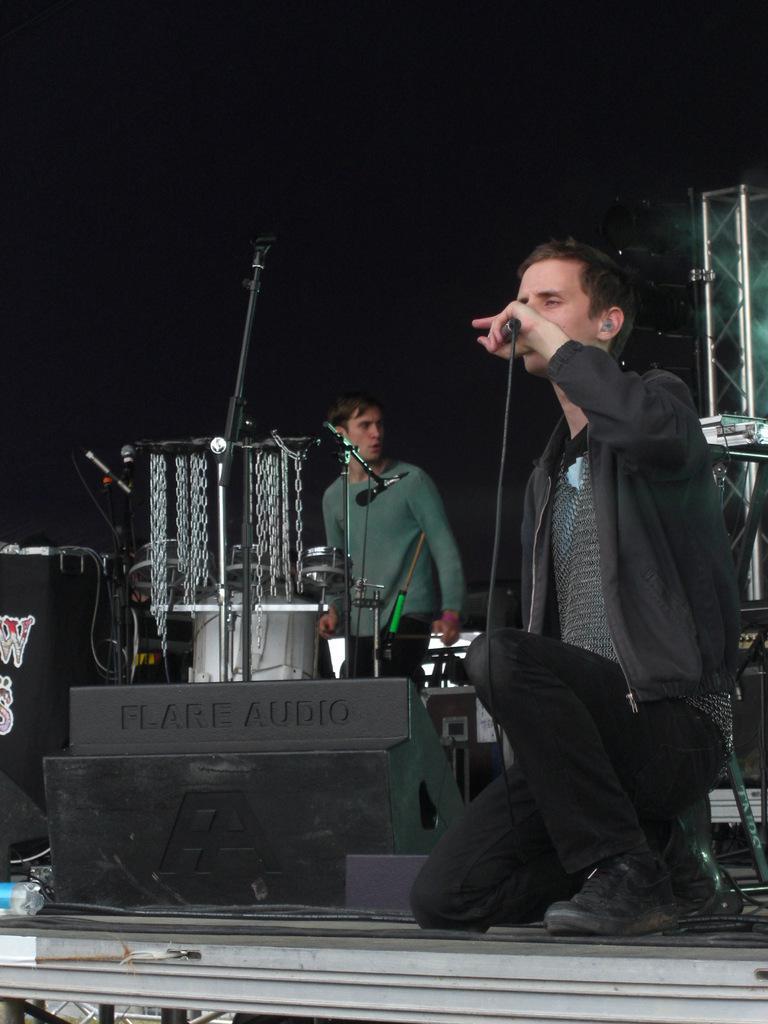In one or two sentences, can you explain what this image depicts? In this picture we can see two men where one is standing and other is sitting on knees he is holding mic in his hand and in background we can see stands, chains and it is dark. 